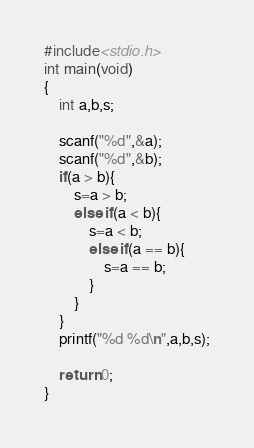<code> <loc_0><loc_0><loc_500><loc_500><_C_>#include<stdio.h>
int main(void)
{
    int a,b,s;
    
    scanf("%d",&a);
    scanf("%d",&b);
    if(a > b){
        s=a > b;
        else if(a < b){
            s=a < b;
            else if(a == b){
                s=a == b;
            }
        }
    }
    printf("%d %d\n",a,b,s);
    
    return 0;
}
</code> 